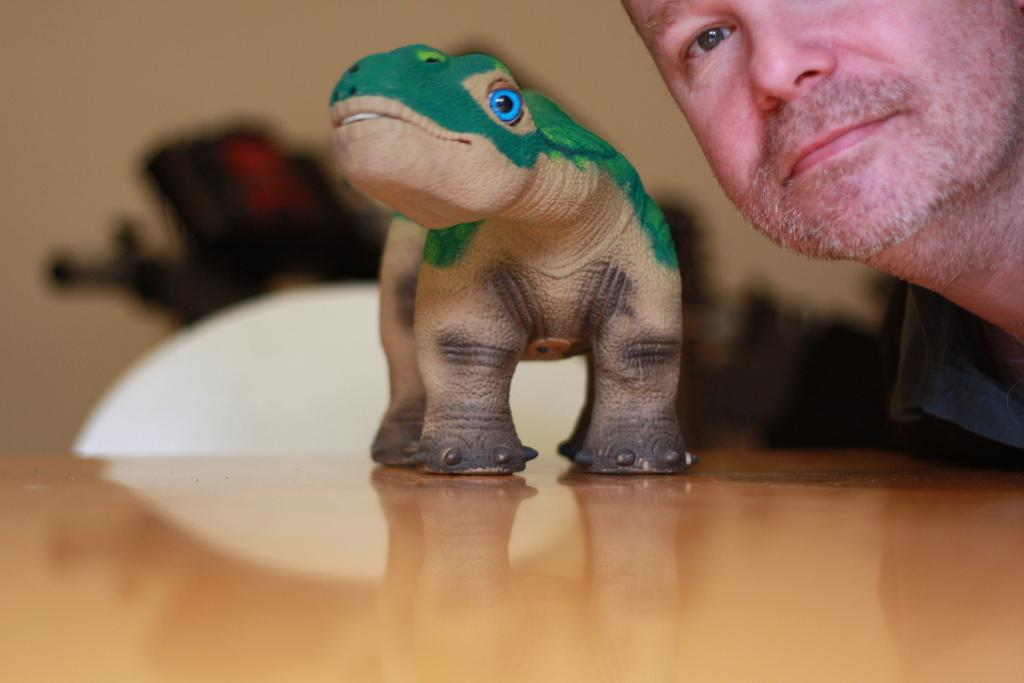What object is on the table in the image? There is a dragon toy on a table in the image. Can you describe the person in the image? There is a person in the top right corner of the image. What can be said about the background of the image? The background of the image is blurred. How does the person in the image apply friction to the dragon toy? There is no indication in the image that the person is interacting with the dragon toy, nor is there any information about friction. 